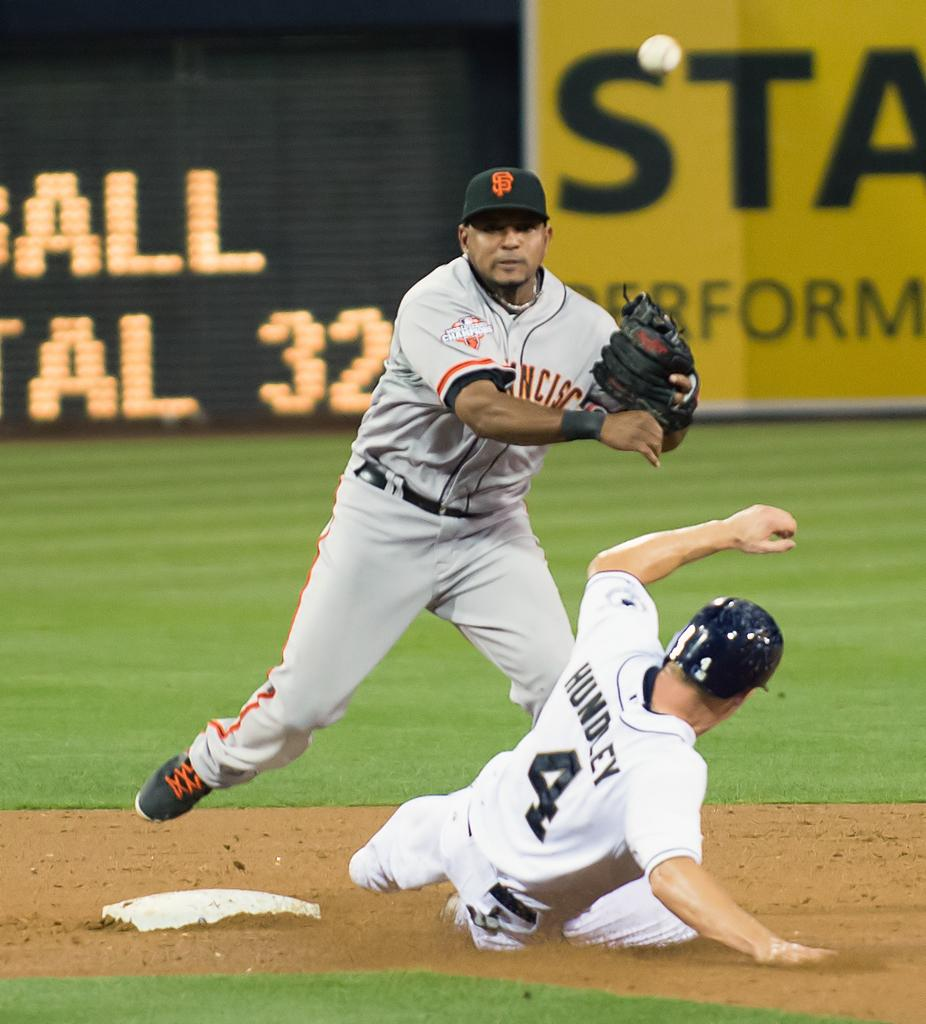<image>
Share a concise interpretation of the image provided. Baesball player wearing number 4 sliding on to the base. 